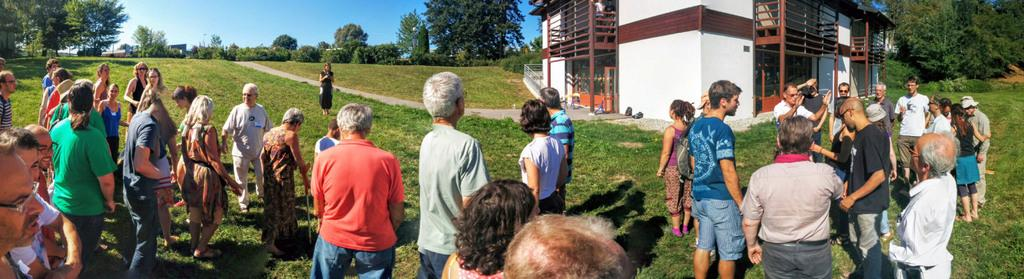What are the people in the image standing on? The people in the image are standing on the grass. What color is the grass? The grass is green. What structure can be seen in the image? There is a house in the image. What type of vegetation is present in the image? There are trees in the image. What color is the sky in the image? The sky is blue at the top of the image. Reasoning: Let's think step by step by step in order to produce the conversation. We start by identifying the main subjects and objects in the image based on the provided facts. We then formulate questions that focus on the location and characteristics of these subjects and objects, ensuring that each question can be answered definitively with the information given. We avoid yes/no questions and ensure that the language is simple and clear. Absurd Question/Answer: What type of produce is being harvested by the people in the image? There is no produce or harvesting activity depicted in the image. Can you see a bat flying in the sky in the image? There is no bat visible in the image; the sky is blue at the top of the image. What type of journey are the people in the image embarking on? There is no indication of a journey in the image; the people are simply standing on the grass. Can you see a bat flying in the sky in the image? There is no bat visible in the image; the sky is blue at the top of the image. 